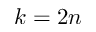<formula> <loc_0><loc_0><loc_500><loc_500>k = 2 n</formula> 